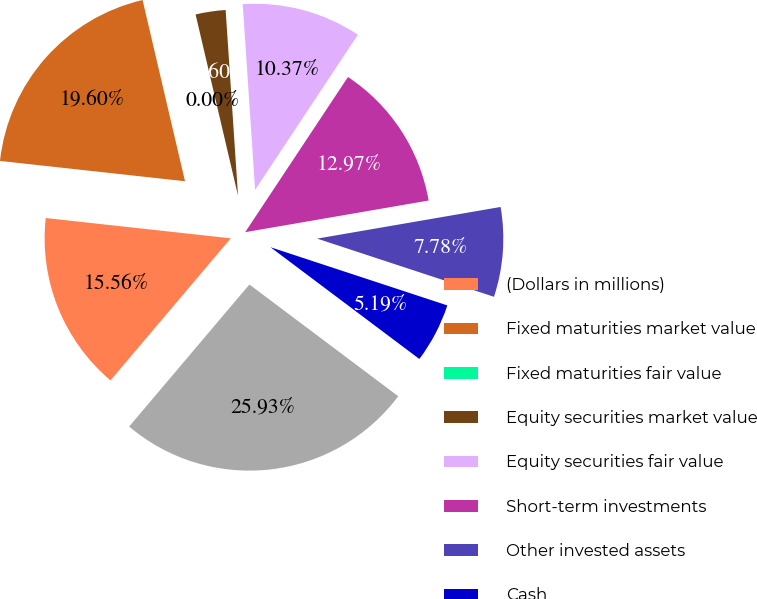Convert chart. <chart><loc_0><loc_0><loc_500><loc_500><pie_chart><fcel>(Dollars in millions)<fcel>Fixed maturities market value<fcel>Fixed maturities fair value<fcel>Equity securities market value<fcel>Equity securities fair value<fcel>Short-term investments<fcel>Other invested assets<fcel>Cash<fcel>Total investments and cash<nl><fcel>15.56%<fcel>19.6%<fcel>0.0%<fcel>2.6%<fcel>10.37%<fcel>12.97%<fcel>7.78%<fcel>5.19%<fcel>25.93%<nl></chart> 